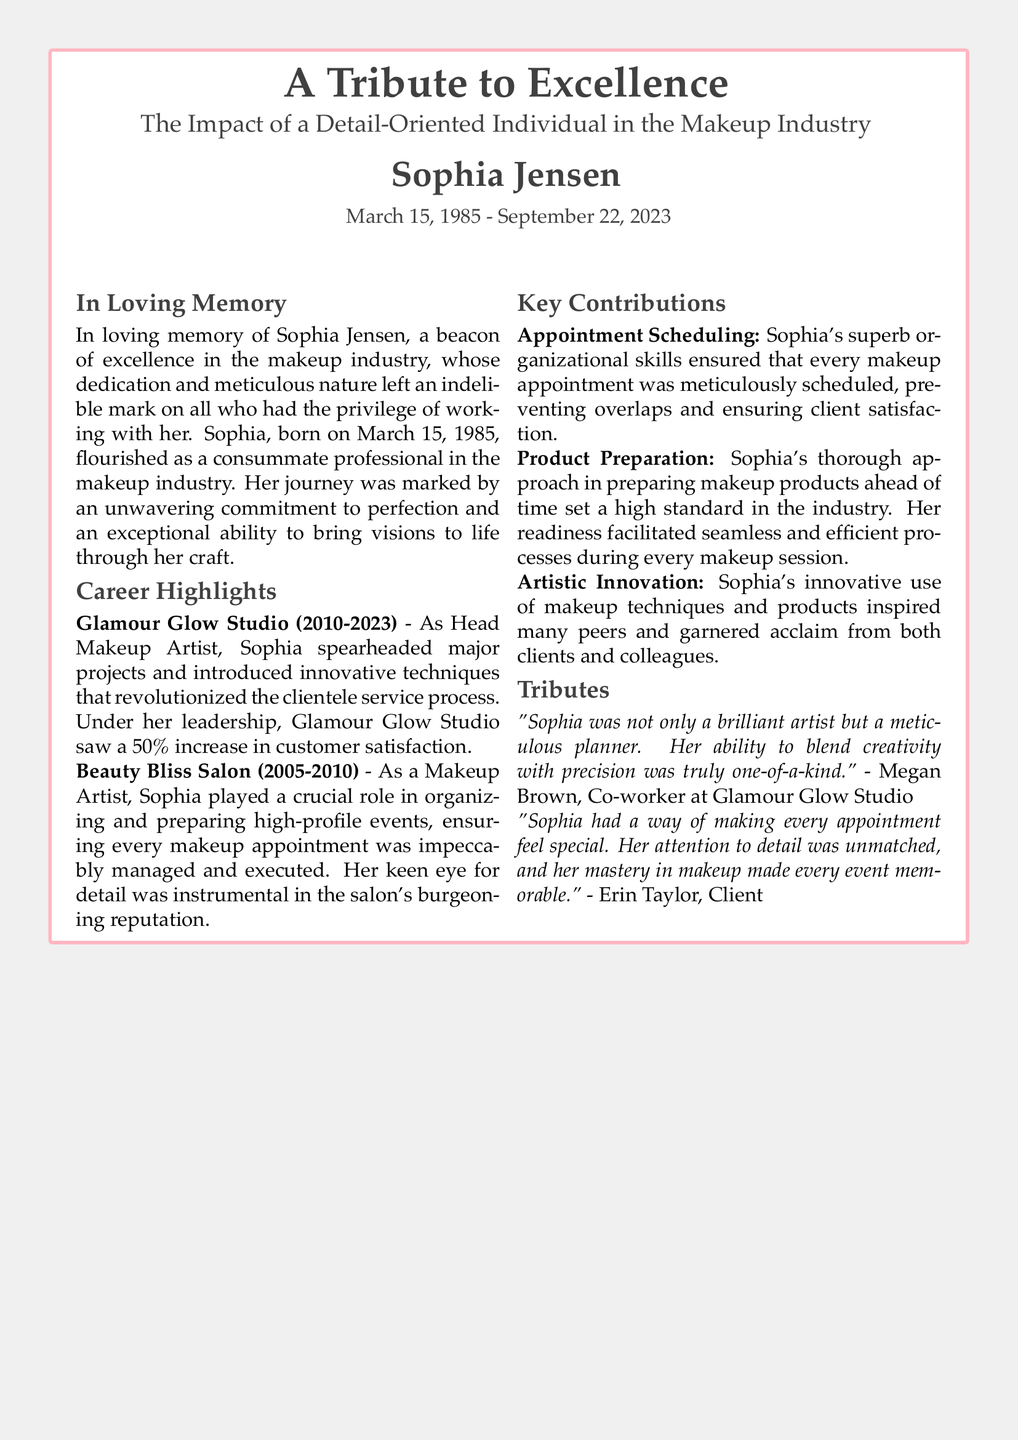What is the full name of the individual honored in the obituary? The full name of the individual honored is Sophia Jensen, as stated prominently at the beginning of the document.
Answer: Sophia Jensen What were the years of Sophia Jensen's life? The years of Sophia Jensen's life are mentioned in the subtitle, specifying her birth and death dates.
Answer: March 15, 1985 - September 22, 2023 Which studio did Sophia work for as Head Makeup Artist? The document specifies Sofia's role at Glamour Glow Studio, where she served as Head Makeup Artist.
Answer: Glamour Glow Studio How much did customer satisfaction increase under Sophia's leadership? The document highlights the 50% increase in customer satisfaction at Glamour Glow Studio as a significant achievement during Sophia's leadership.
Answer: 50% What key skill did Sophia possess that was crucial for appointment management? The document mentions Sophia's superb organizational skills in the context of scheduling appointments effectively.
Answer: Organizational skills Who described Sophia's detail orientation as unmatched? A client named Erin Taylor is quoted in the document, praising Sophia's unmatched attention to detail.
Answer: Erin Taylor What was Sophia Jensen's role at Beauty Bliss Salon? The document states that she worked as a Makeup Artist at Beauty Bliss Salon, contributing to the salon's reputation.
Answer: Makeup Artist What aspect of Sophia's work set a high standard in the industry? The document highlights her thorough approach in preparing makeup products as a key contribution to setting industry standards.
Answer: Product Preparation Who was a co-worker of Sophia's at Glamour Glow Studio? The document cites Megan Brown as a co-worker who provided a tribute to Sophia.
Answer: Megan Brown 